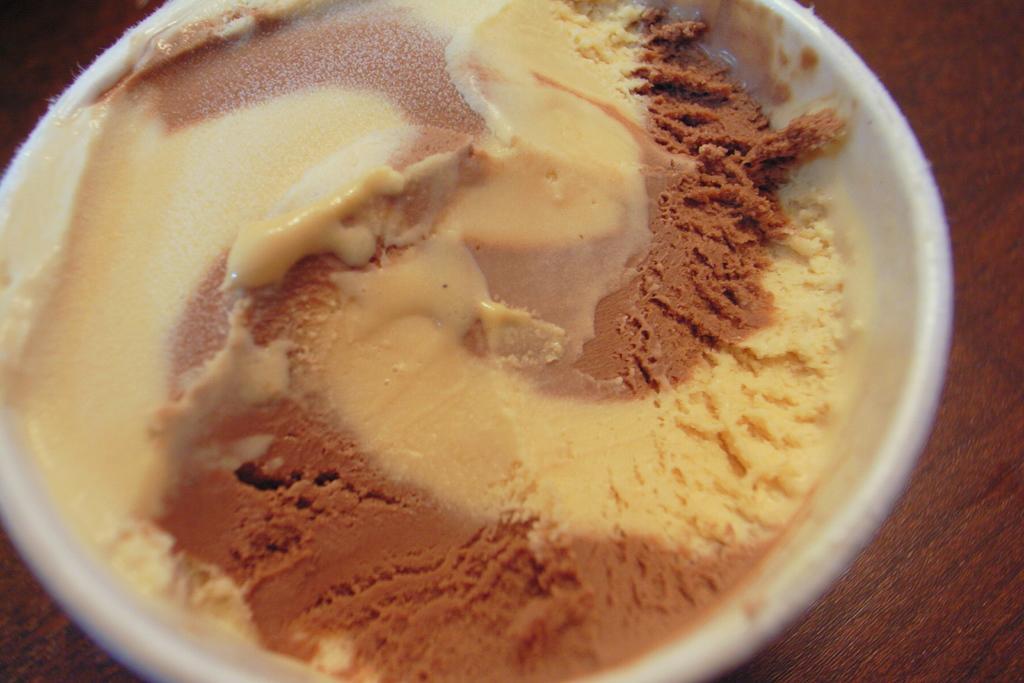Describe this image in one or two sentences. In this image, there is bowl contains some food. 